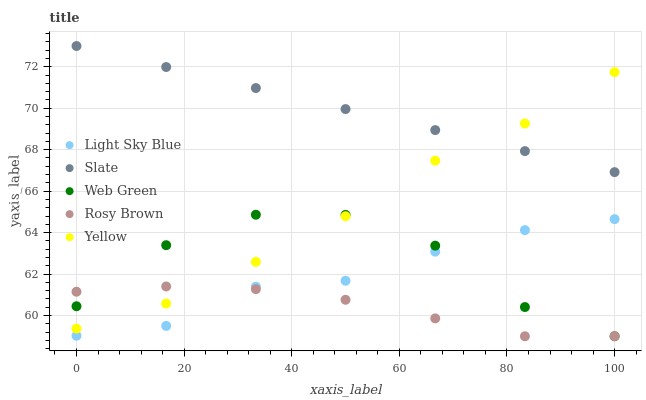Does Rosy Brown have the minimum area under the curve?
Answer yes or no. Yes. Does Slate have the maximum area under the curve?
Answer yes or no. Yes. Does Light Sky Blue have the minimum area under the curve?
Answer yes or no. No. Does Light Sky Blue have the maximum area under the curve?
Answer yes or no. No. Is Slate the smoothest?
Answer yes or no. Yes. Is Web Green the roughest?
Answer yes or no. Yes. Is Light Sky Blue the smoothest?
Answer yes or no. No. Is Light Sky Blue the roughest?
Answer yes or no. No. Does Rosy Brown have the lowest value?
Answer yes or no. Yes. Does Light Sky Blue have the lowest value?
Answer yes or no. No. Does Slate have the highest value?
Answer yes or no. Yes. Does Light Sky Blue have the highest value?
Answer yes or no. No. Is Light Sky Blue less than Yellow?
Answer yes or no. Yes. Is Yellow greater than Light Sky Blue?
Answer yes or no. Yes. Does Rosy Brown intersect Yellow?
Answer yes or no. Yes. Is Rosy Brown less than Yellow?
Answer yes or no. No. Is Rosy Brown greater than Yellow?
Answer yes or no. No. Does Light Sky Blue intersect Yellow?
Answer yes or no. No. 